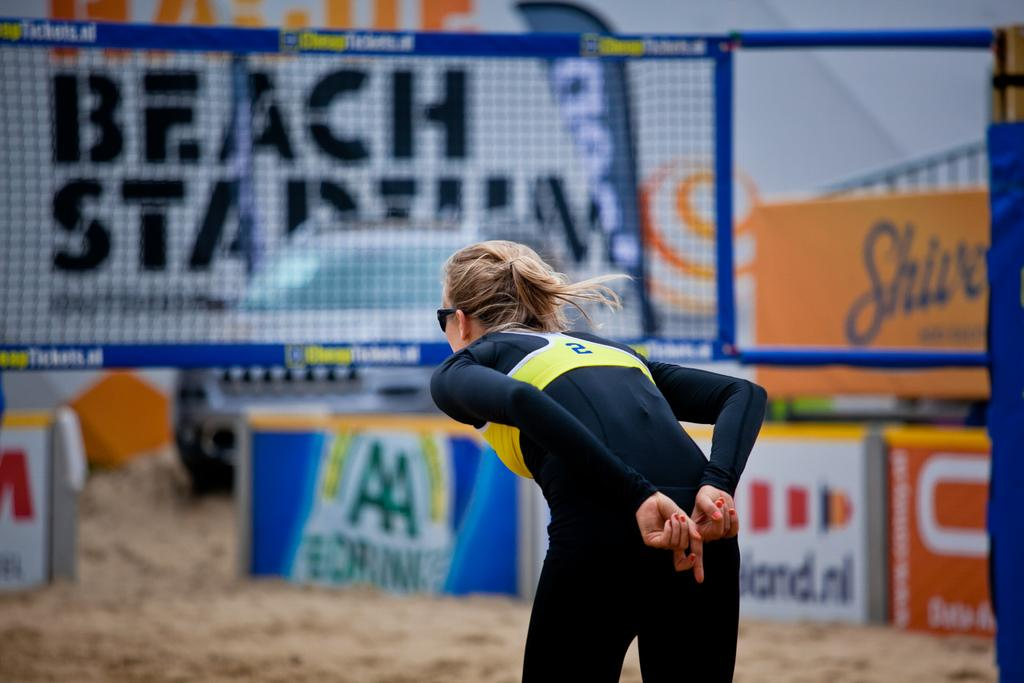Who is the main subject in the image? There is a lady in the image. What is the lady wearing on her face? The lady is wearing goggles. What can be seen in the background of the image? There are banners in the background of the image. What is written on the banners? There is text on the banners. What object resembles a net in the image? There is an object that resembles a net in the image. Can you tell me how many kittens are playing with the lady's brother in the image? There is no mention of a brother or kittens in the image; it features a lady wearing goggles with banners and a net-like object in the background. 